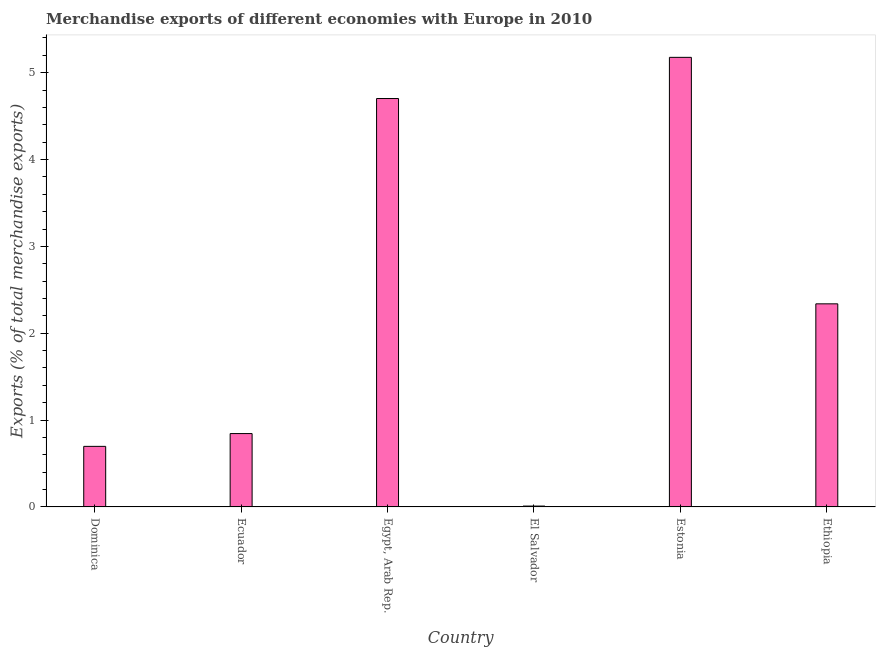Does the graph contain any zero values?
Give a very brief answer. No. What is the title of the graph?
Provide a succinct answer. Merchandise exports of different economies with Europe in 2010. What is the label or title of the Y-axis?
Your response must be concise. Exports (% of total merchandise exports). What is the merchandise exports in Estonia?
Provide a short and direct response. 5.18. Across all countries, what is the maximum merchandise exports?
Offer a very short reply. 5.18. Across all countries, what is the minimum merchandise exports?
Offer a terse response. 0.01. In which country was the merchandise exports maximum?
Keep it short and to the point. Estonia. In which country was the merchandise exports minimum?
Your answer should be very brief. El Salvador. What is the sum of the merchandise exports?
Give a very brief answer. 13.77. What is the difference between the merchandise exports in Egypt, Arab Rep. and Estonia?
Your answer should be compact. -0.47. What is the average merchandise exports per country?
Your answer should be very brief. 2.29. What is the median merchandise exports?
Provide a short and direct response. 1.59. What is the ratio of the merchandise exports in Ecuador to that in Estonia?
Provide a succinct answer. 0.16. Is the merchandise exports in Ecuador less than that in Estonia?
Make the answer very short. Yes. Is the difference between the merchandise exports in Ecuador and Estonia greater than the difference between any two countries?
Provide a short and direct response. No. What is the difference between the highest and the second highest merchandise exports?
Your answer should be very brief. 0.47. Is the sum of the merchandise exports in Dominica and Ecuador greater than the maximum merchandise exports across all countries?
Make the answer very short. No. What is the difference between the highest and the lowest merchandise exports?
Ensure brevity in your answer.  5.17. How many bars are there?
Provide a short and direct response. 6. What is the Exports (% of total merchandise exports) in Dominica?
Give a very brief answer. 0.7. What is the Exports (% of total merchandise exports) in Ecuador?
Keep it short and to the point. 0.84. What is the Exports (% of total merchandise exports) of Egypt, Arab Rep.?
Make the answer very short. 4.7. What is the Exports (% of total merchandise exports) of El Salvador?
Make the answer very short. 0.01. What is the Exports (% of total merchandise exports) in Estonia?
Your answer should be compact. 5.18. What is the Exports (% of total merchandise exports) in Ethiopia?
Provide a succinct answer. 2.34. What is the difference between the Exports (% of total merchandise exports) in Dominica and Ecuador?
Provide a succinct answer. -0.15. What is the difference between the Exports (% of total merchandise exports) in Dominica and Egypt, Arab Rep.?
Your response must be concise. -4.01. What is the difference between the Exports (% of total merchandise exports) in Dominica and El Salvador?
Provide a succinct answer. 0.69. What is the difference between the Exports (% of total merchandise exports) in Dominica and Estonia?
Ensure brevity in your answer.  -4.48. What is the difference between the Exports (% of total merchandise exports) in Dominica and Ethiopia?
Your answer should be very brief. -1.64. What is the difference between the Exports (% of total merchandise exports) in Ecuador and Egypt, Arab Rep.?
Offer a terse response. -3.86. What is the difference between the Exports (% of total merchandise exports) in Ecuador and El Salvador?
Provide a succinct answer. 0.83. What is the difference between the Exports (% of total merchandise exports) in Ecuador and Estonia?
Provide a short and direct response. -4.33. What is the difference between the Exports (% of total merchandise exports) in Ecuador and Ethiopia?
Offer a very short reply. -1.49. What is the difference between the Exports (% of total merchandise exports) in Egypt, Arab Rep. and El Salvador?
Your answer should be compact. 4.69. What is the difference between the Exports (% of total merchandise exports) in Egypt, Arab Rep. and Estonia?
Give a very brief answer. -0.47. What is the difference between the Exports (% of total merchandise exports) in Egypt, Arab Rep. and Ethiopia?
Keep it short and to the point. 2.36. What is the difference between the Exports (% of total merchandise exports) in El Salvador and Estonia?
Keep it short and to the point. -5.17. What is the difference between the Exports (% of total merchandise exports) in El Salvador and Ethiopia?
Your answer should be very brief. -2.33. What is the difference between the Exports (% of total merchandise exports) in Estonia and Ethiopia?
Offer a very short reply. 2.84. What is the ratio of the Exports (% of total merchandise exports) in Dominica to that in Ecuador?
Your answer should be compact. 0.82. What is the ratio of the Exports (% of total merchandise exports) in Dominica to that in Egypt, Arab Rep.?
Your answer should be very brief. 0.15. What is the ratio of the Exports (% of total merchandise exports) in Dominica to that in El Salvador?
Offer a very short reply. 70.19. What is the ratio of the Exports (% of total merchandise exports) in Dominica to that in Estonia?
Give a very brief answer. 0.14. What is the ratio of the Exports (% of total merchandise exports) in Dominica to that in Ethiopia?
Your answer should be compact. 0.3. What is the ratio of the Exports (% of total merchandise exports) in Ecuador to that in Egypt, Arab Rep.?
Give a very brief answer. 0.18. What is the ratio of the Exports (% of total merchandise exports) in Ecuador to that in El Salvador?
Provide a short and direct response. 85.03. What is the ratio of the Exports (% of total merchandise exports) in Ecuador to that in Estonia?
Give a very brief answer. 0.16. What is the ratio of the Exports (% of total merchandise exports) in Ecuador to that in Ethiopia?
Ensure brevity in your answer.  0.36. What is the ratio of the Exports (% of total merchandise exports) in Egypt, Arab Rep. to that in El Salvador?
Make the answer very short. 473.4. What is the ratio of the Exports (% of total merchandise exports) in Egypt, Arab Rep. to that in Estonia?
Offer a very short reply. 0.91. What is the ratio of the Exports (% of total merchandise exports) in Egypt, Arab Rep. to that in Ethiopia?
Provide a short and direct response. 2.01. What is the ratio of the Exports (% of total merchandise exports) in El Salvador to that in Estonia?
Give a very brief answer. 0. What is the ratio of the Exports (% of total merchandise exports) in El Salvador to that in Ethiopia?
Provide a short and direct response. 0. What is the ratio of the Exports (% of total merchandise exports) in Estonia to that in Ethiopia?
Offer a terse response. 2.21. 